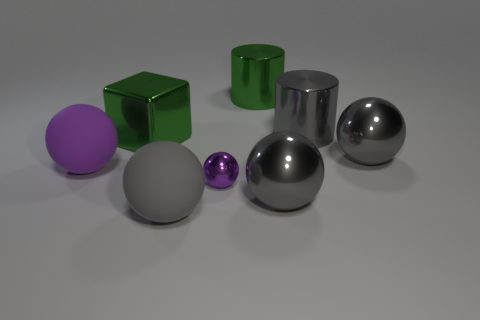There is a big shiny ball left of the sphere behind the big purple thing; what is its color? The big shiny ball to the left of the smaller spherical object, which is itself behind the large purple sphere, has a reflective, silver-gray color. Its smooth surface mirrors the environment and lighting around it, giving it a gleaming appearance. 